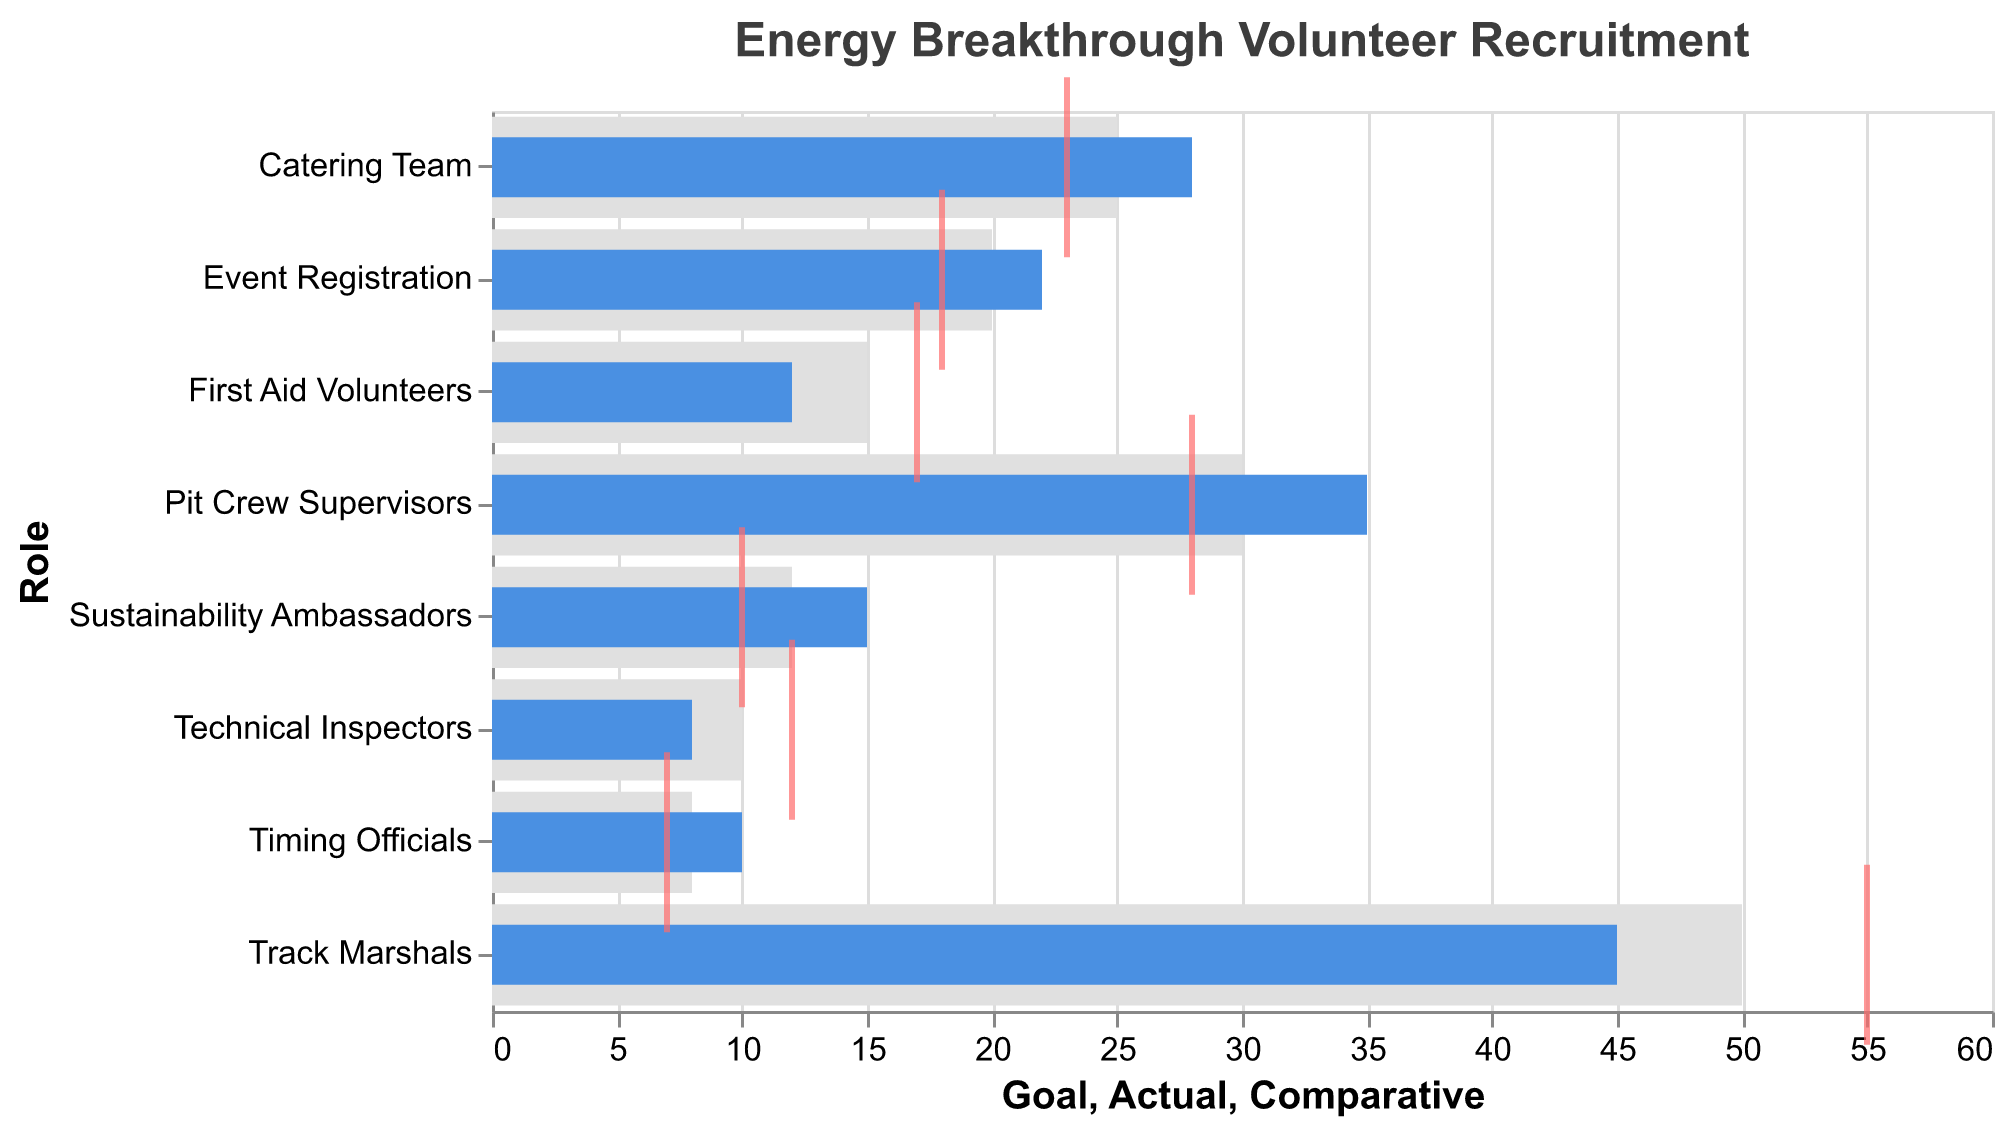Which role had the highest recruitment goal? The data shows different roles with their respective recruitment goals. The role with the highest recruitment goal is the one with the largest number in the "Goal" column. Here, "Track Marshals" has a goal of 50, which is the highest among all roles.
Answer: Track Marshals What is the difference between the actual and comparative values for Pit Crew Supervisors? Find the "Actual" and "Comparative" values for Pit Crew Supervisors and subtract the Comparative value from the Actual value. For Pit Crew Supervisors, the Actual is 35 and the Comparative is 28. The difference is 35 - 28 = 7.
Answer: 7 Which role surpassed its recruitment goal by the largest margin? To find which role surpassed its recruitment goal by the largest margin, calculate the difference between the "Actual" and "Goal" for each role and identify the role with the maximum positive difference. The largest positive difference is in Pit Crew Supervisors where Actual (35) - Goal (30) = 5.
Answer: Pit Crew Supervisors How many roles had an actual number of volunteers greater than their goals? Compare the "Actual" and "Goal" values for each role. Count how many roles have Actual greater than Goal. These roles are Pit Crew Supervisors (35 > 30), Event Registration (22 > 20), Catering Team (28 > 25), Timing Officials (10 > 8), and Sustainability Ambassadors (15 > 12), making the total 5 roles.
Answer: 5 Which role had the most significant shortfall from its recruitment goal? Find the role where the "Actual" is less than the "Goal" by the largest margin. Calculate the difference for roles where Actual < Goal. For Track Marshals, the difference is 50 - 45 = 5. The largest shortfall is Track Marshals.
Answer: Track Marshals What is the average actual number of volunteers for roles with a comparative value lower than the goal? Identify roles where the "Comparative" value is lower than the "Goal" and then calculate the average "Actual" number for those roles. These roles are Event Registration (Actual = 22), Catering Team (Actual = 28), Technical Inspectors (Actual = 8), Timing Officials (Actual = 10), and Sustainability Ambassadors (Actual = 15). The sum of Actual values is 22 + 28 + 8 + 10 + 15 = 83; the average is 83 / 5 = 16.6.
Answer: 16.6 Which roles exactly met their recruitment goal? Check if any roles have their "Actual" value exactly equal to their "Goal." In this dataset, no role has Actual equal to Goal.
Answer: None How does the actual number of volunteers for First Aid Volunteers compare to Sustainability Ambassadors? Compare the "Actual" numbers for First Aid Volunteers and Sustainability Ambassadors. First Aid Volunteers have an Actual of 12, and Sustainability Ambassadors have an Actual of 15; thus, Sustainability Ambassadors have more volunteers.
Answer: Sustainability Ambassadors What is the total number of actual volunteers for all roles combined? Sum the "Actual" numbers for all the roles. The total is 45 (Track Marshals) + 35 (Pit Crew Supervisors) + 22 (Event Registration) + 12 (First Aid Volunteers) + 28 (Catering Team) + 8 (Technical Inspectors) + 10 (Timing Officials) + 15 (Sustainability Ambassadors) = 175.
Answer: 175 